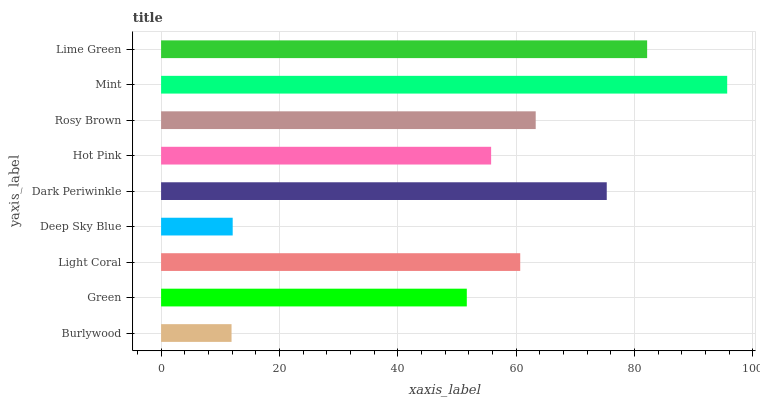Is Burlywood the minimum?
Answer yes or no. Yes. Is Mint the maximum?
Answer yes or no. Yes. Is Green the minimum?
Answer yes or no. No. Is Green the maximum?
Answer yes or no. No. Is Green greater than Burlywood?
Answer yes or no. Yes. Is Burlywood less than Green?
Answer yes or no. Yes. Is Burlywood greater than Green?
Answer yes or no. No. Is Green less than Burlywood?
Answer yes or no. No. Is Light Coral the high median?
Answer yes or no. Yes. Is Light Coral the low median?
Answer yes or no. Yes. Is Burlywood the high median?
Answer yes or no. No. Is Burlywood the low median?
Answer yes or no. No. 